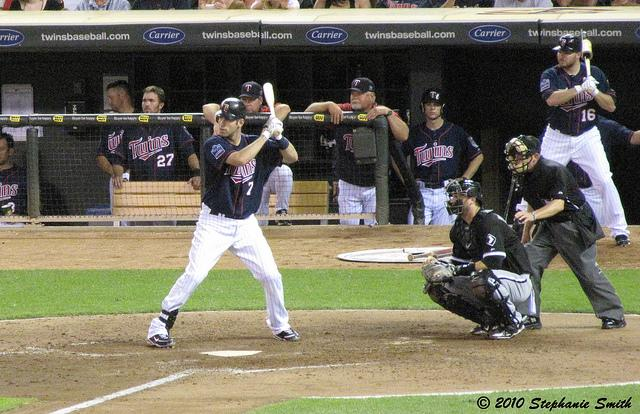What league does the team with the standing players play in?

Choices:
A) nfc south
B) afc east
C) american league
D) national league american league 